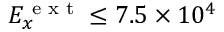Convert formula to latex. <formula><loc_0><loc_0><loc_500><loc_500>E _ { x } ^ { e x t } \leq 7 . 5 \times 1 0 ^ { 4 }</formula> 